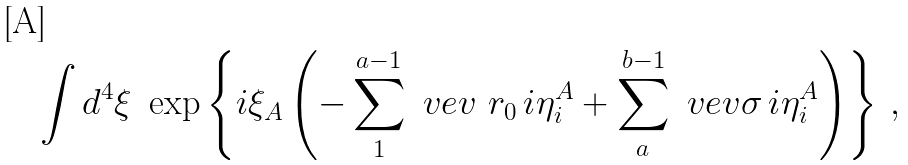<formula> <loc_0><loc_0><loc_500><loc_500>\int d ^ { 4 } \xi \ \exp \left \{ i \xi _ { A } \left ( - \sum _ { 1 } ^ { a - 1 } \ v e v { \ r _ { 0 } \, i } \eta ^ { A } _ { i } + \sum _ { a } ^ { b - 1 } \ v e v { \sigma \, i } \eta ^ { A } _ { i } \right ) \right \} \, ,</formula> 